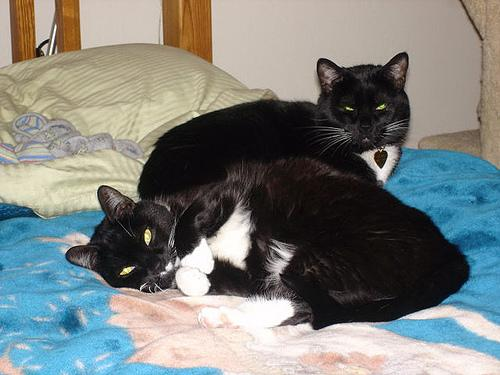What is the facial feature that stands out for the cat looking at the camera? The cat has bright yellow eyes and white whiskers coming off its face. List the main items you can see in the image and their colors. Two cats (black and white), green pillow, fuzzy blue blanket, beige rugcovered cat tree, wooden posts, blue and white striped pillow, white whiskers What is one of the cat's front paws like, and what does it have around its neck? The cat has white front paws and a collar with a heart-shaped pendant around its neck. Mention the color of the blanket under the cats and the type of pattern on the pillow. The blanket under the cats is blue and there's a pillow with a yellow-striped pattern. Specify the type of cats present in the image. There are two tuxedo cats laying down on the bed. What kind of object is behind the two cats? There's a brown wooden frame and a white wall behind the cats. Explain the position of the cat tree in relation to the cats. The beige rugcovered cat tree is positioned to the right of the two cats. What is special about one of the cats' tag? One cat has a heart-shaped tag hanging from its collar. Give a brief description of the bed and its appearance. The bed has a blue and white blanket, a green pillow, and a pillow with a white striped case, and is covered by a fuzzy blue blanket. Describe what the cats are doing and where they are located. The two cats are lying down on a bed with a blue and white blanket, pillows, and a fuzzy blue blanket. 